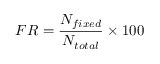Convert formula to latex. <formula><loc_0><loc_0><loc_500><loc_500>F R = \frac { N _ { f i x e d } } { N _ { t o t a l } } \times 1 0 0 \</formula> 